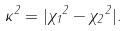Convert formula to latex. <formula><loc_0><loc_0><loc_500><loc_500>\kappa ^ { 2 } = | { \chi _ { 1 } } ^ { 2 } - { \chi _ { 2 } } ^ { 2 } | .</formula> 